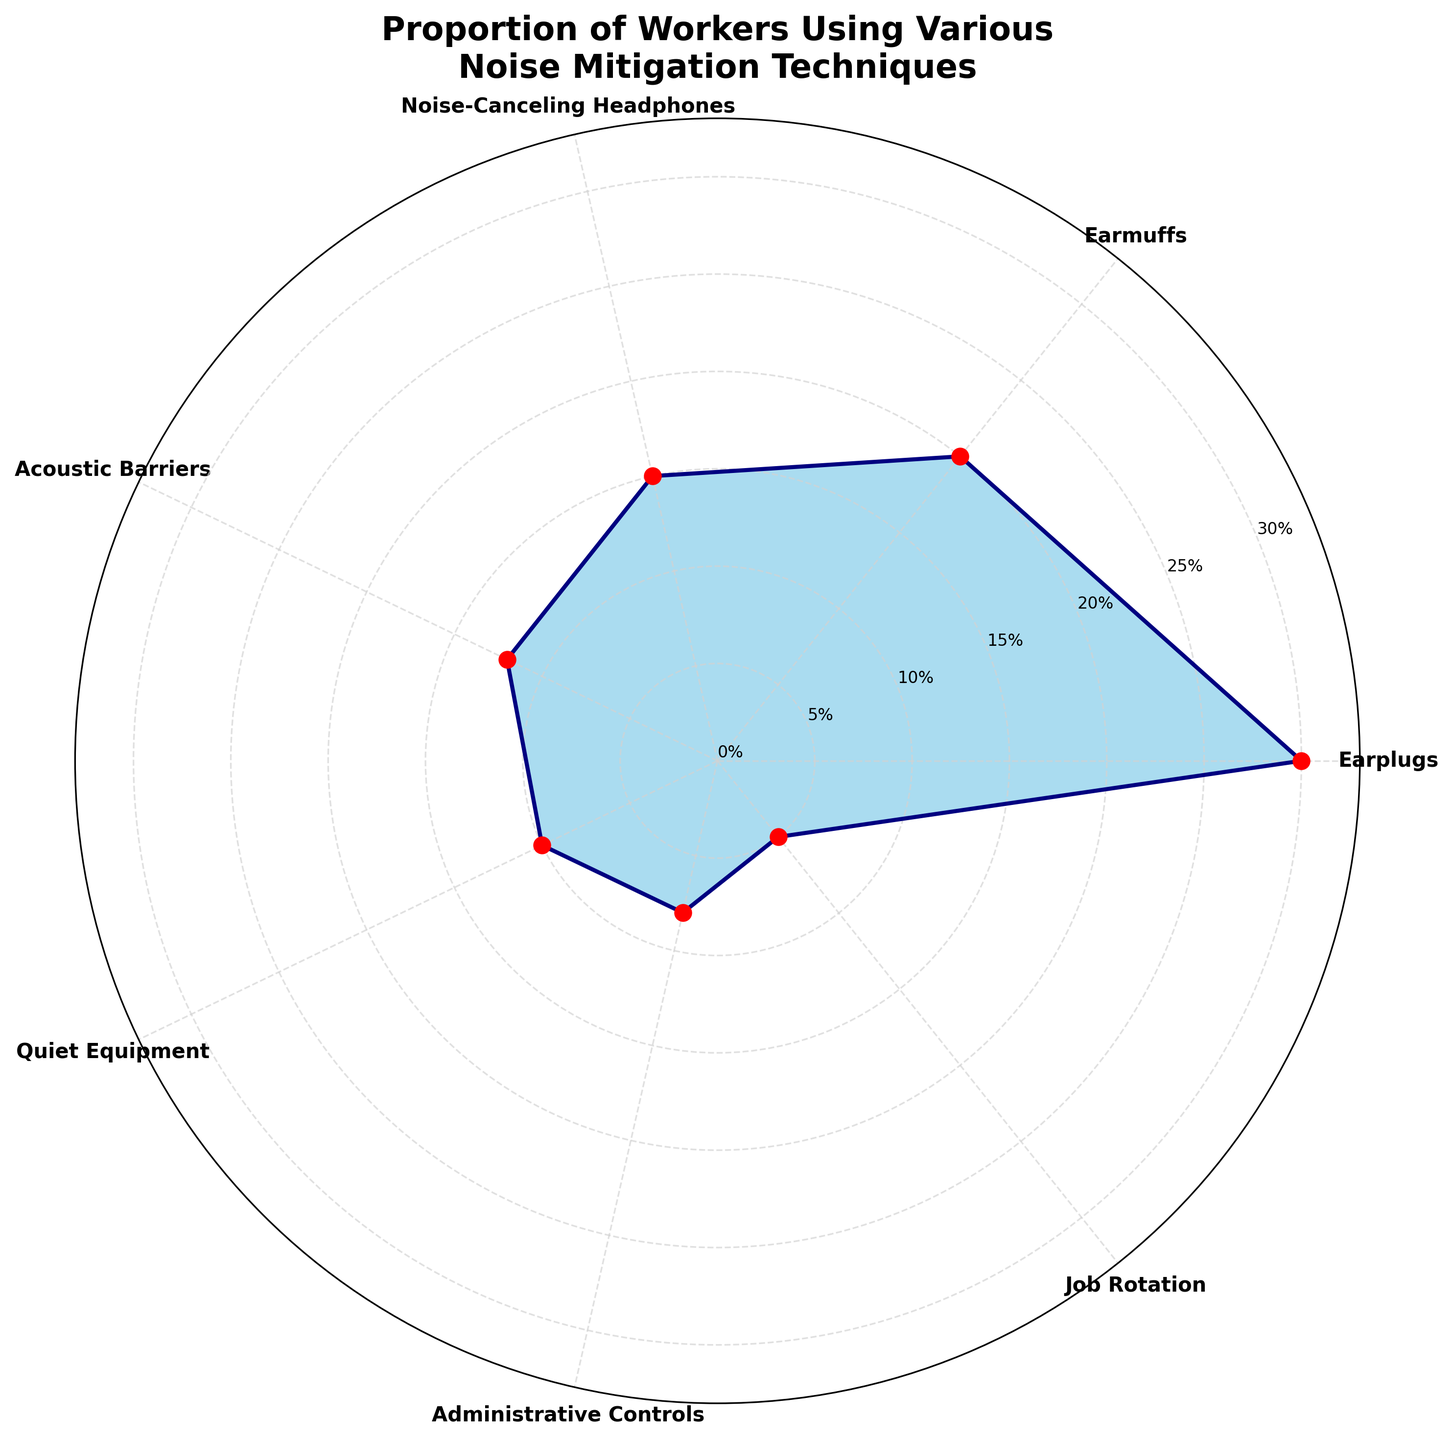What is the title of the figure? The title of the figure can be found at the top of the chart. It reads "Proportion of Workers Using Various Noise Mitigation Techniques".
Answer: Proportion of Workers Using Various Noise Mitigation Techniques How many different noise mitigation techniques are shown in the figure? The figure displays techniques on a polar grid with labeled ticks. Each distinct label represents a different technique. By counting them, you find seven techniques.
Answer: 7 Which noise mitigation technique is used by the highest proportion of workers? Look at the plot and identify the technique with the largest value (i.e., the longest segment from the center). The "Earplugs" segment is the longest.
Answer: Earplugs What is the proportion of workers that use earmuffs? Find the segment labeled "Earmuffs" and trace it to its value on the radial axis. The label indicates 20%.
Answer: 20% Calculate the combined proportion of workers using earmuffs and acoustic barriers. The figure gives a proportion of 20% for earmuffs and 12% for acoustic barriers. Adding these values, you get 20% + 12% = 32%.
Answer: 32% Are more workers using earplugs or noise-canceling headphones? Compare the lengths of the segments for "Earplugs" and "Noise-Canceling Headphones." The earplugs segment is larger.
Answer: Earplugs What is the difference in the proportion of workers using quiet equipment and job rotation? The figure shows 10% for quiet equipment and 5% for job rotation. Subtract the smaller value from the larger one: 10% - 5% = 5%.
Answer: 5% Which two techniques have the smallest combined proportion of use? Look for the two smallest segments. Administrative controls (8%) and job rotation (5%) are the two smallest. Their combined proportion is 8% + 5% = 13%.
Answer: Administrative Controls and Job Rotation What percentage of workers use noise-canceling headphones or quiet equipment? The figure shows 15% for noise-canceling headphones and 10% for quiet equipment. Adding these gives 15% + 10% = 25%.
Answer: 25% How much more popular are earplugs compared to administrative controls? The proportion for earplugs is 30%, and for administrative controls, it is 8%. Subtract the latter from the former: 30% - 8% = 22%.
Answer: 22% 